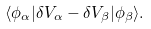<formula> <loc_0><loc_0><loc_500><loc_500>\langle \phi _ { \alpha } | \delta V _ { \alpha } - \delta V _ { \beta } | \phi _ { \beta } \rangle .</formula> 